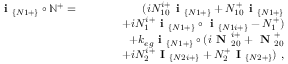Convert formula to latex. <formula><loc_0><loc_0><loc_500><loc_500>\begin{array} { r l r } { i _ { \{ N 1 + \} } \circ \mathbb { N } ^ { + } = } & { ( i N _ { 1 0 } ^ { i + } i _ { \{ N 1 + \} } + N _ { 1 0 } ^ { + } i _ { \{ N 1 + \} } } \\ & { + i N _ { 1 } ^ { i + } i _ { \{ N 1 + \} } \circ i _ { \{ N 1 i + \} } - N _ { 1 } ^ { + } ) } \\ & { + k _ { e g } i _ { \{ N 1 + \} } \circ ( i N _ { 2 0 } ^ { i + } + N _ { 2 0 } ^ { + } } \\ & { + i N _ { 2 } ^ { i + } I _ { \{ N 2 i + \} } + N _ { 2 } ^ { + } I _ { \{ N 2 + \} } ) , } \end{array}</formula> 